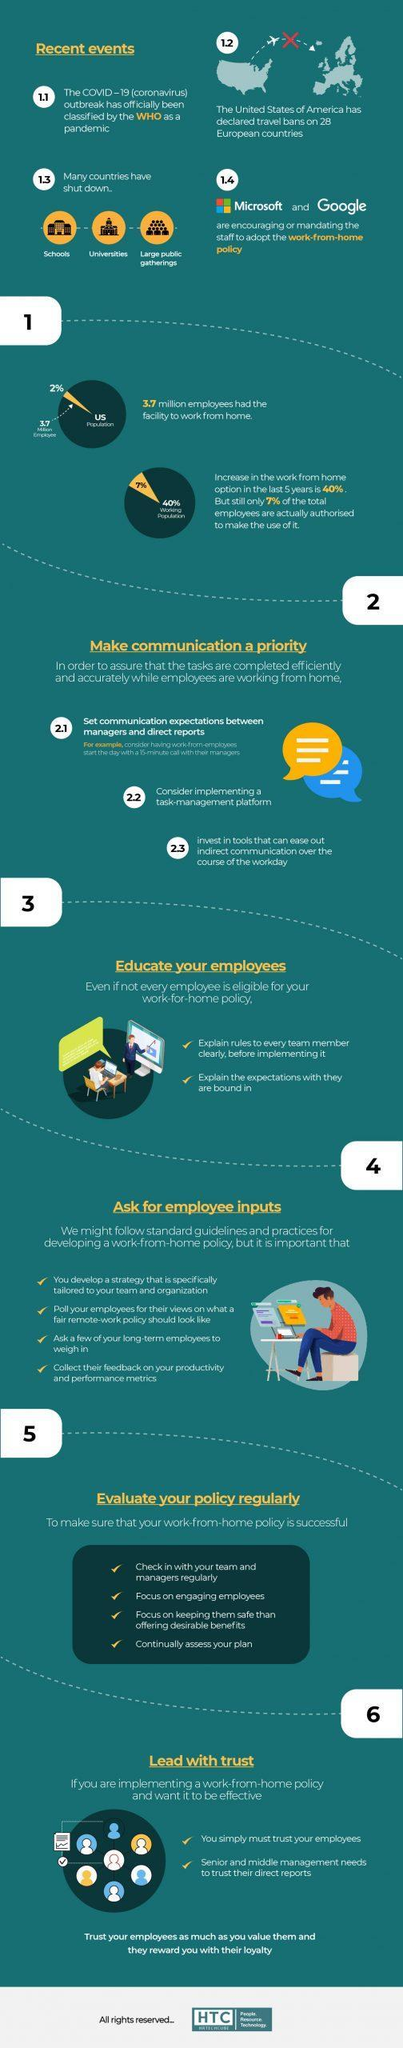How many points are under the heading "Ask for employee inputs"?
Answer the question with a short phrase. 4 How many companies are encouraging work-from-home policy? 2 How many points are under the heading "Educate your employees"? 2 